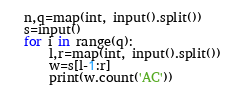<code> <loc_0><loc_0><loc_500><loc_500><_Python_>n,q=map(int, input().split())
s=input()
for i in range(q):
    l,r=map(int, input().split())
    w=s[l-1:r]
    print(w.count('AC'))</code> 